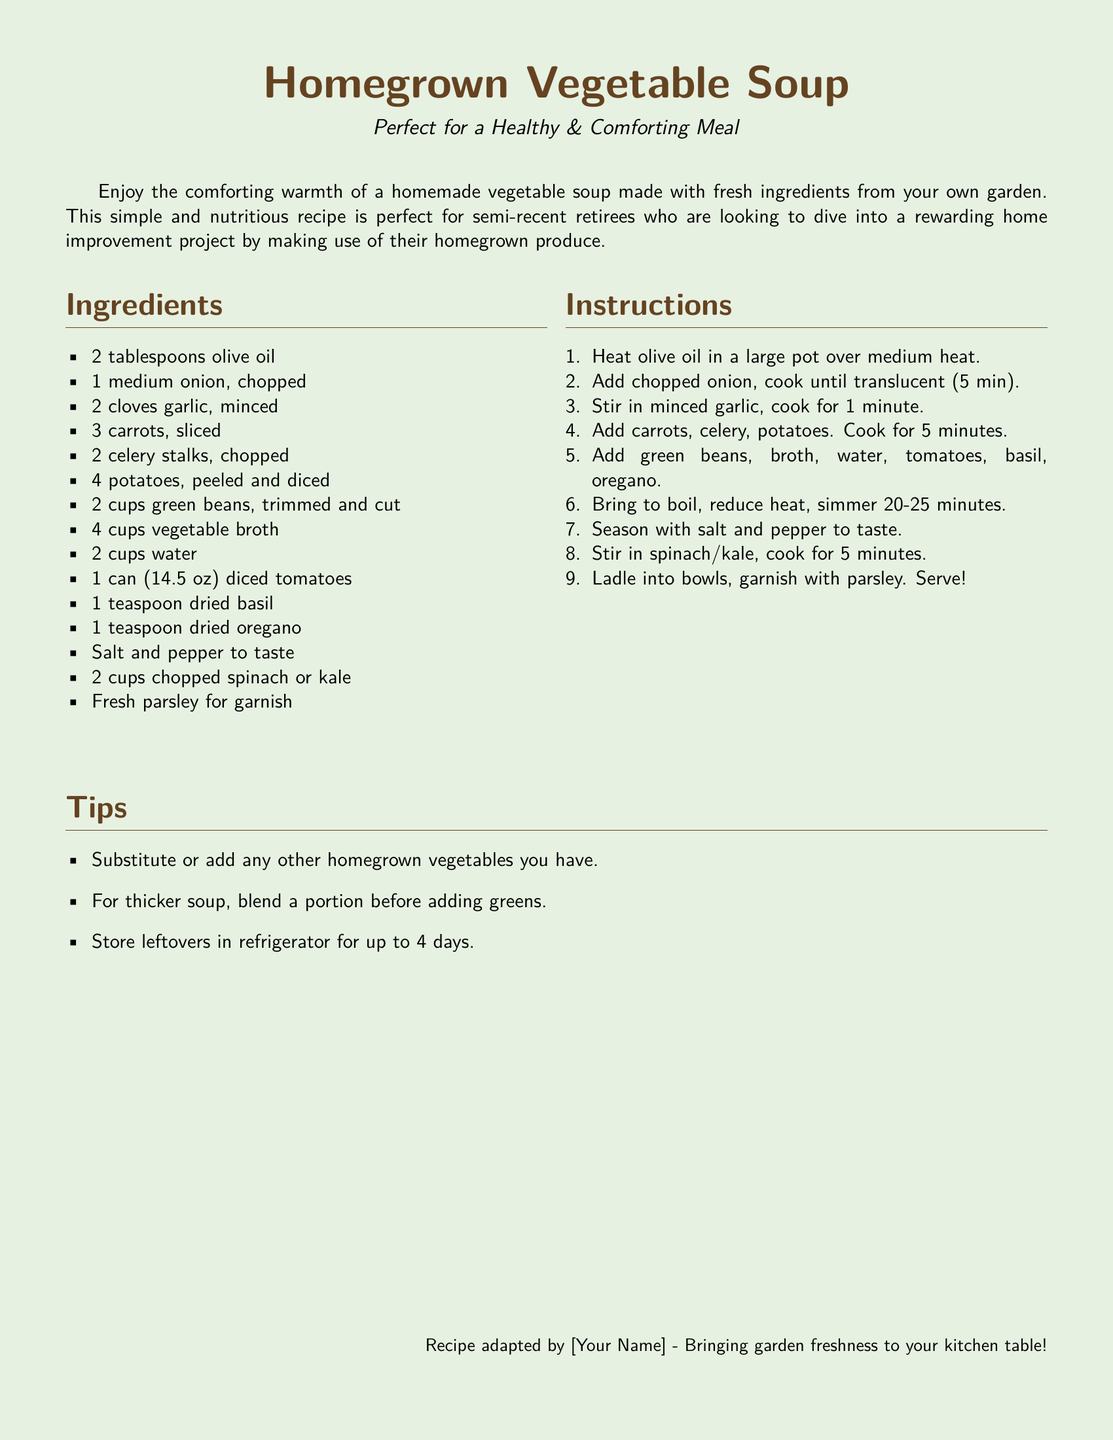What is the main ingredient in the soup? The main ingredient in the soup is made up of various vegetables as listed, but as a specific ingredient, the answer would be the broth.
Answer: vegetable broth How long should the soup simmer? The document states that the soup should simmer for 20-25 minutes after bringing it to a boil.
Answer: 20-25 minutes What type of vegetable oil is used? The recipe specifies that olive oil is used in the preparation of the soup.
Answer: olive oil What are the two leafy vegetables that can be added? The document mentions that spinach or kale can be stirred into the soup for added nutrition.
Answer: spinach or kale What can be used to garnish the soup? The recipe suggests using fresh parsley as a garnish for the soup before serving.
Answer: fresh parsley How many cups of vegetable broth are required? The ingredients list indicates that 4 cups of vegetable broth are needed for the recipe.
Answer: 4 cups What should you do for a thicker soup? The document suggests blending a portion of the soup prior to adding the greens for a thicker consistency.
Answer: blend a portion What is a recommended storage duration for leftovers? The recipe advises that leftovers can be stored in the refrigerator for up to 4 days.
Answer: 4 days What is the purpose of the recipe card? The main purpose outlined in the document is to create a simple and nutritious meal using homegrown vegetables.
Answer: create a simple and nutritious meal 